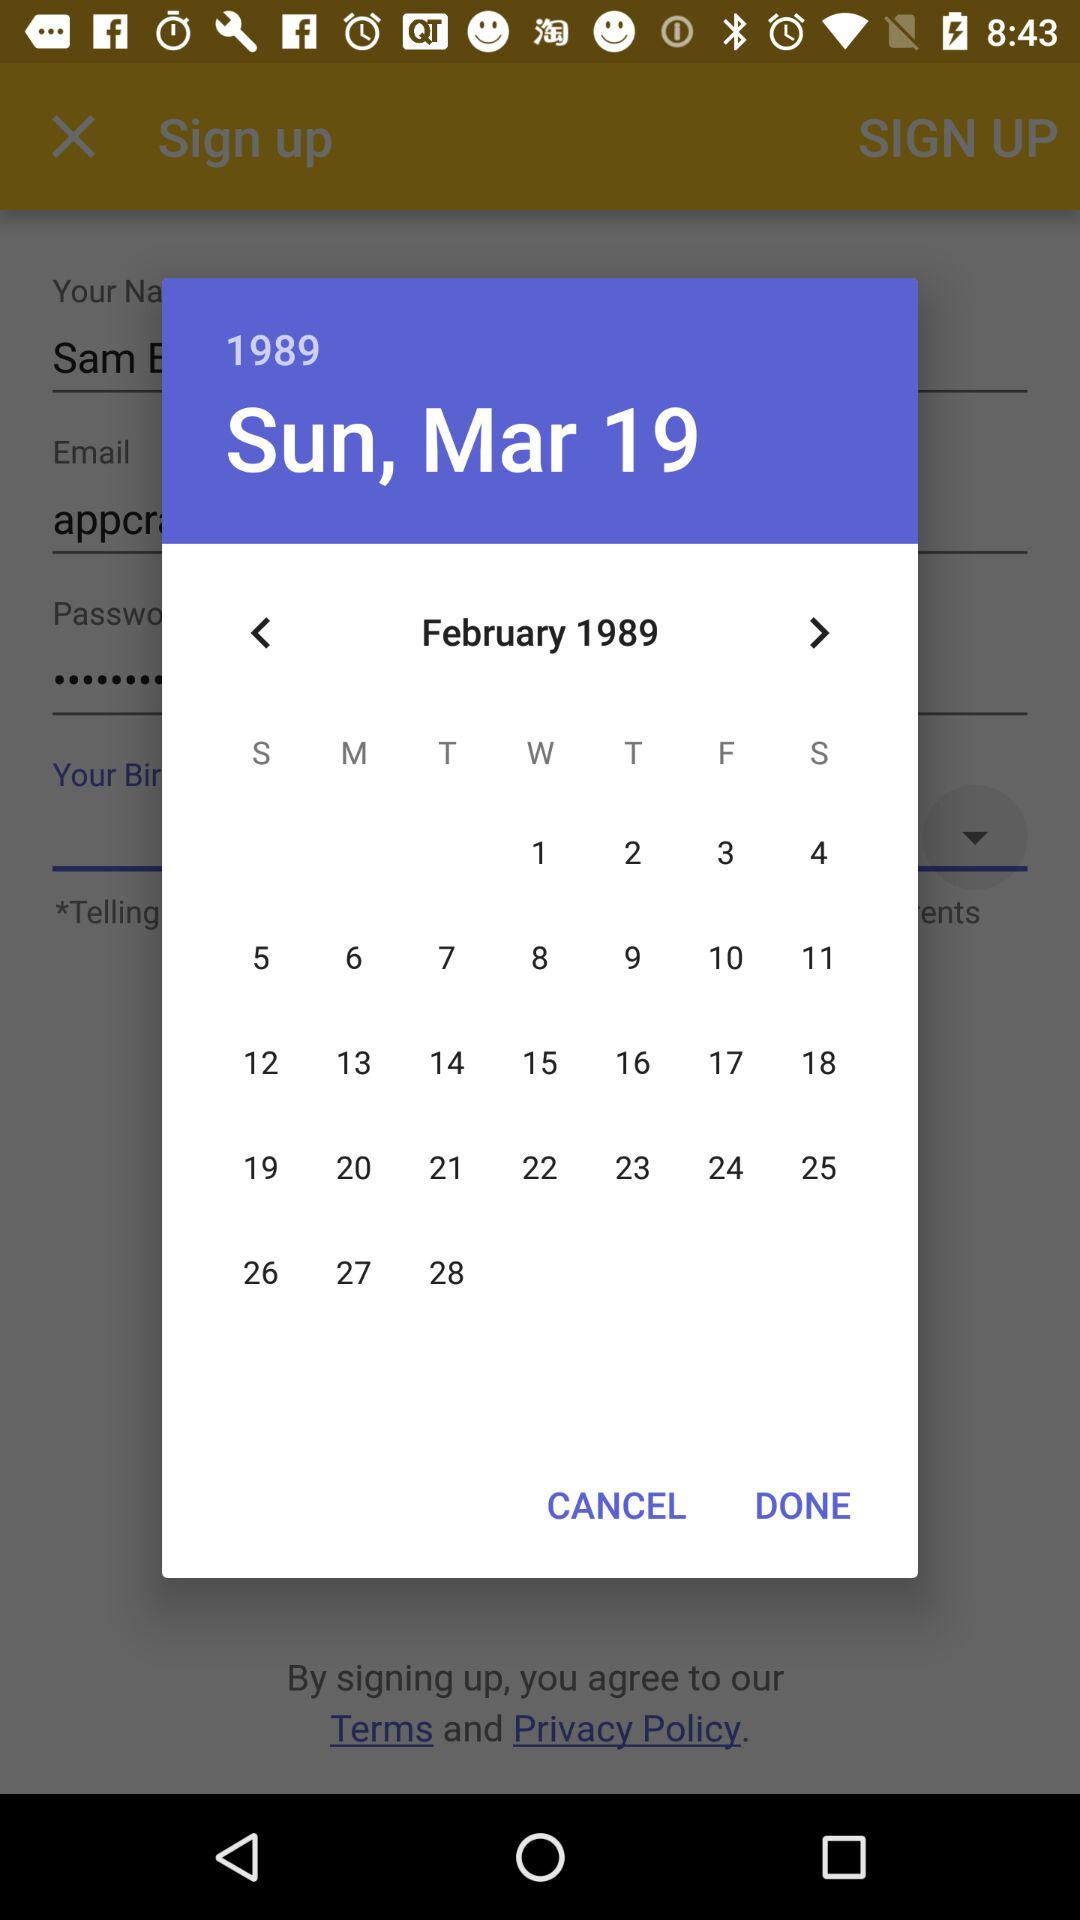Which day is February 1, 1989? The day is Wednesday. 